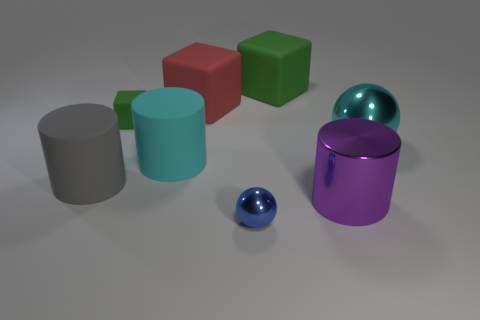Add 1 large things. How many objects exist? 9 Subtract all balls. How many objects are left? 6 Subtract 0 gray balls. How many objects are left? 8 Subtract all tiny purple rubber things. Subtract all small green rubber cubes. How many objects are left? 7 Add 4 large green cubes. How many large green cubes are left? 5 Add 4 big blue metallic balls. How many big blue metallic balls exist? 4 